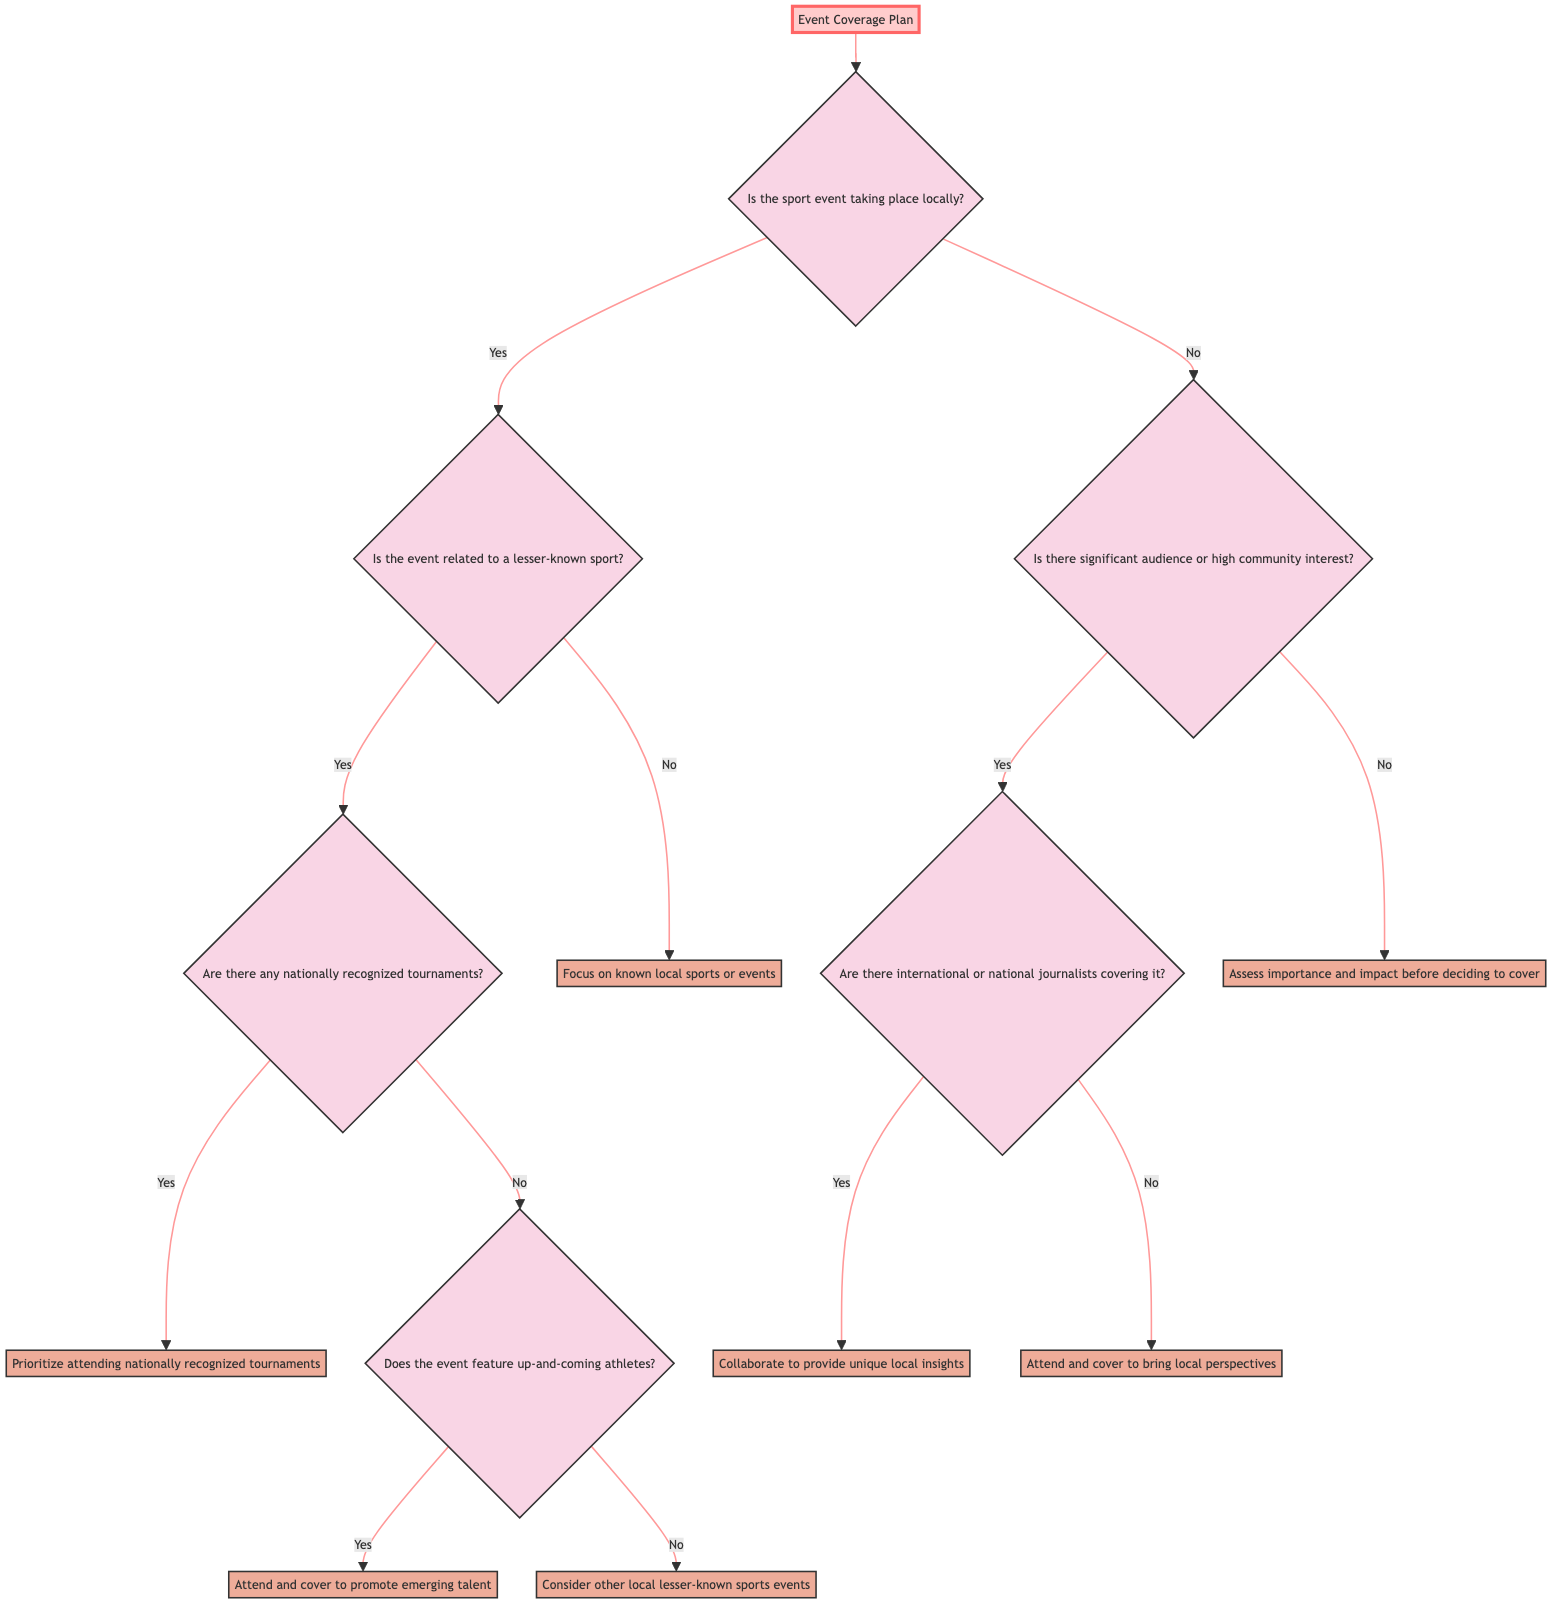What is the first question to consider in the decision tree? The first question in the diagram is about whether the sport event is taking place locally. It is the initial decision point that directs the flow of the decision-making process.
Answer: Is the sport event taking place locally? How many decision nodes are there in the diagram? By counting the nodes that represent decisions in the diagram, it is evident that there are four distinct decision nodes: the first decision about locality, the second about the sport type, the third regarding recognized tournaments, and the fourth regarding journalist coverage.
Answer: Four What does the decision node state if the sport event is not local? If the sport event is not local, the decision node asks if there is significant audience or high community interest in the event, indicating consideration of external factors when evaluating coverage potential.
Answer: Is there significant audience or high community interest? What is the outcome if the event featured up-and-coming athletes but was not a nationally recognized tournament? If the event features up-and-coming athletes and is not a nationally recognized tournament, the outcome is to attend and cover the event to promote emerging talent, highlighting the focus on fostering new potential stars in the sporting community.
Answer: Attend and cover to promote emerging talent If there is significant audience interest and no national journalists covering the event, what should be done? If there is significant audience interest and no national journalists covering the event, the recommendation is to attend and cover the event to bring local perspectives, ensuring that local stories and viewpoints are shared.
Answer: Attend and cover to bring local perspectives What happens when a nationally recognized tournament is happening locally? In the situation where there is a nationally recognized tournament taking place locally, the decision is to prioritize attending that tournament, indicating an emphasis on high-profile events despite other local considerations.
Answer: Prioritize attending nationally recognized tournaments What should be assessed if there is no significant audience interest in a non-local event? If there is no significant audience interest in a non-local event, the advice is to assess the importance and impact of the event before deciding to cover it, which allows for strategic consideration of which events are meaningful enough to warrant coverage.
Answer: Assess importance and impact before deciding to cover What is indicated when there are international or national journalists at a local event? When there are international or national journalists covering a local event, the indication is to collaborate with those journalists to provide unique local insights, leveraging their presence to enrich the coverage being offered.
Answer: Collaborate to provide unique local insights 